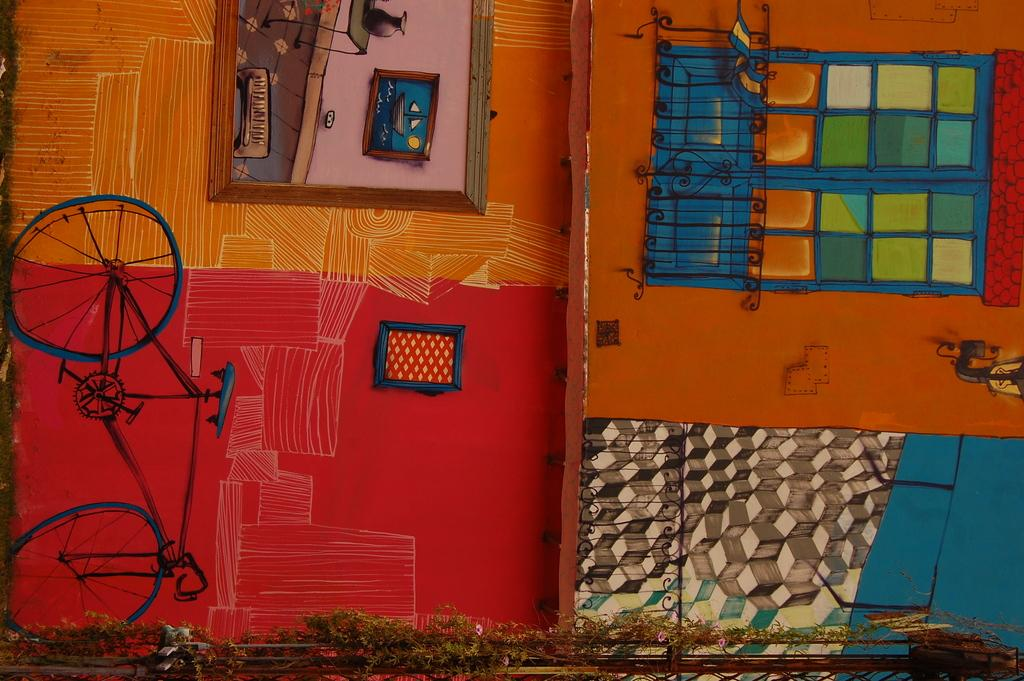What is attached to the wall in the image? There is a frame attached to the wall in the image. What is inside the frame? There are paintings on the wall in the image. What can be observed about the paintings in terms of color? The paintings are in multiple colors. How many rays are emitted from the paintings in the image? There are no rays emitted from the paintings in the image. What unit of measurement is used to determine the size of the paintings in the image? The size of the paintings in the image is not specified, so it is not possible to determine the unit of measurement used. 